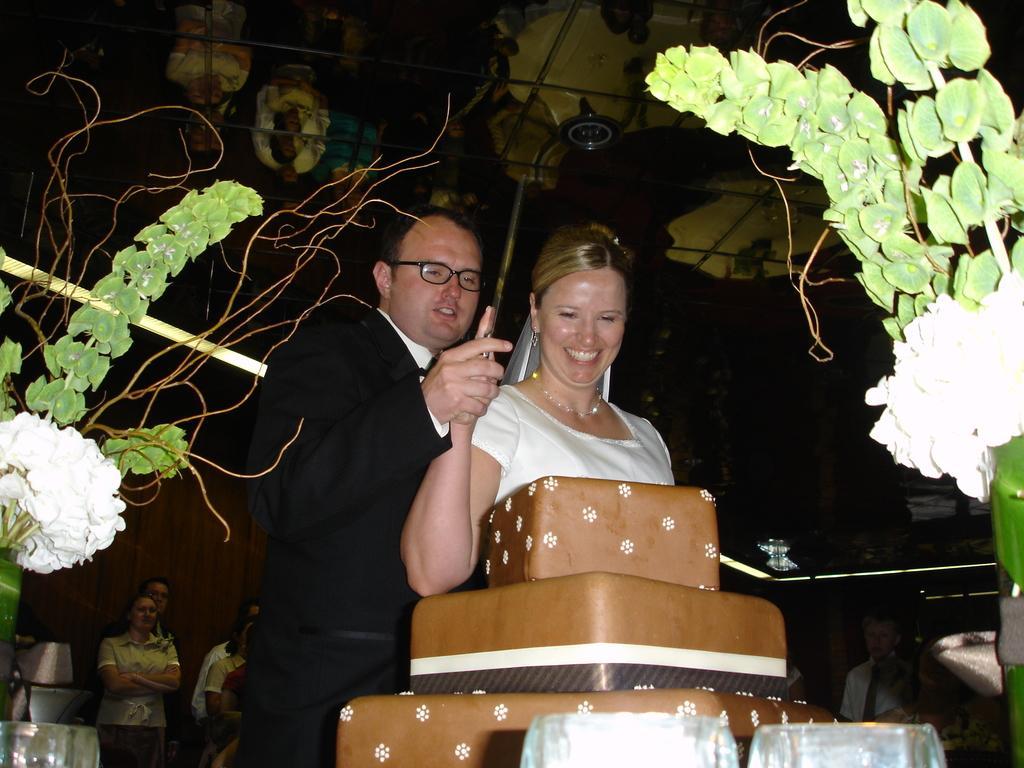Can you describe this image briefly? The man in the black blazer and the woman in the white dress is stunning. She is smiling. She is holding a knife in her hand. He is holding the hand of the woman. In front of them, we see a cake. I think both of them are cutting the cake. On either side of the picture, we see the plastic flower pots. In the background, we see the people are standing. At the top, we see the ceiling of the room. In the left bottom, we see an object in white color. 